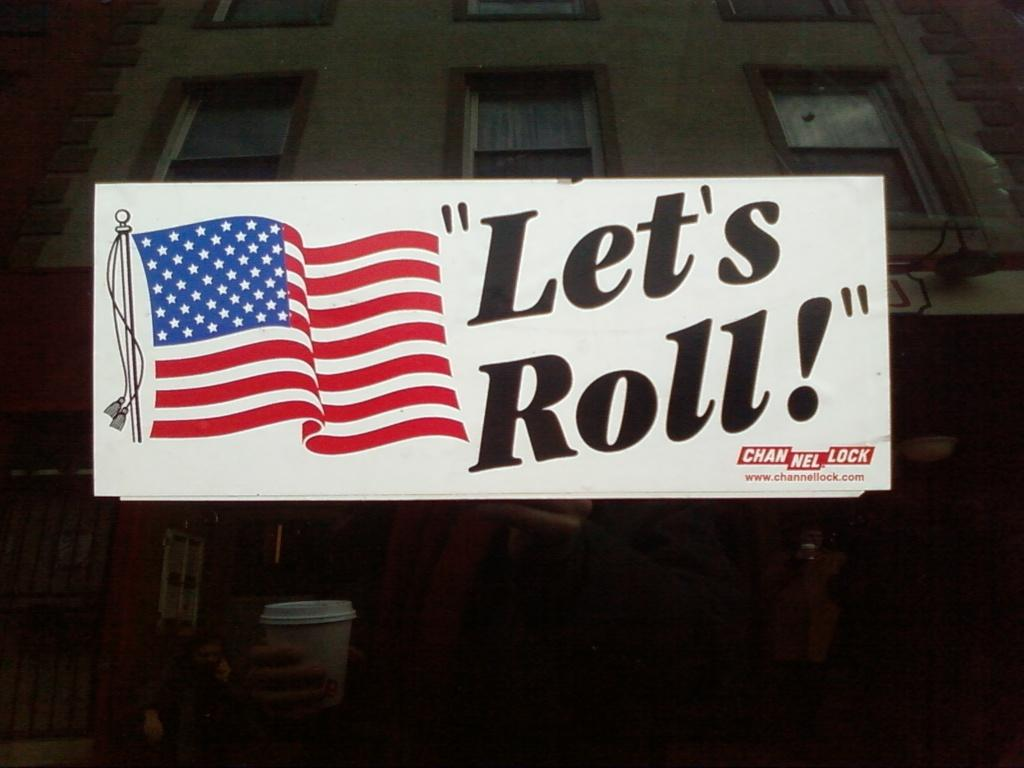What is attached to the mirror in the image? There is a name board pasted on the mirror. What does the mirror reflect in the image? The mirror reflects a building, windows, and persons. What type of substance is visible on the floor in the image? There is no substance visible on the floor in the image. How many eggs are visible in the image? There are no eggs present in the image. 